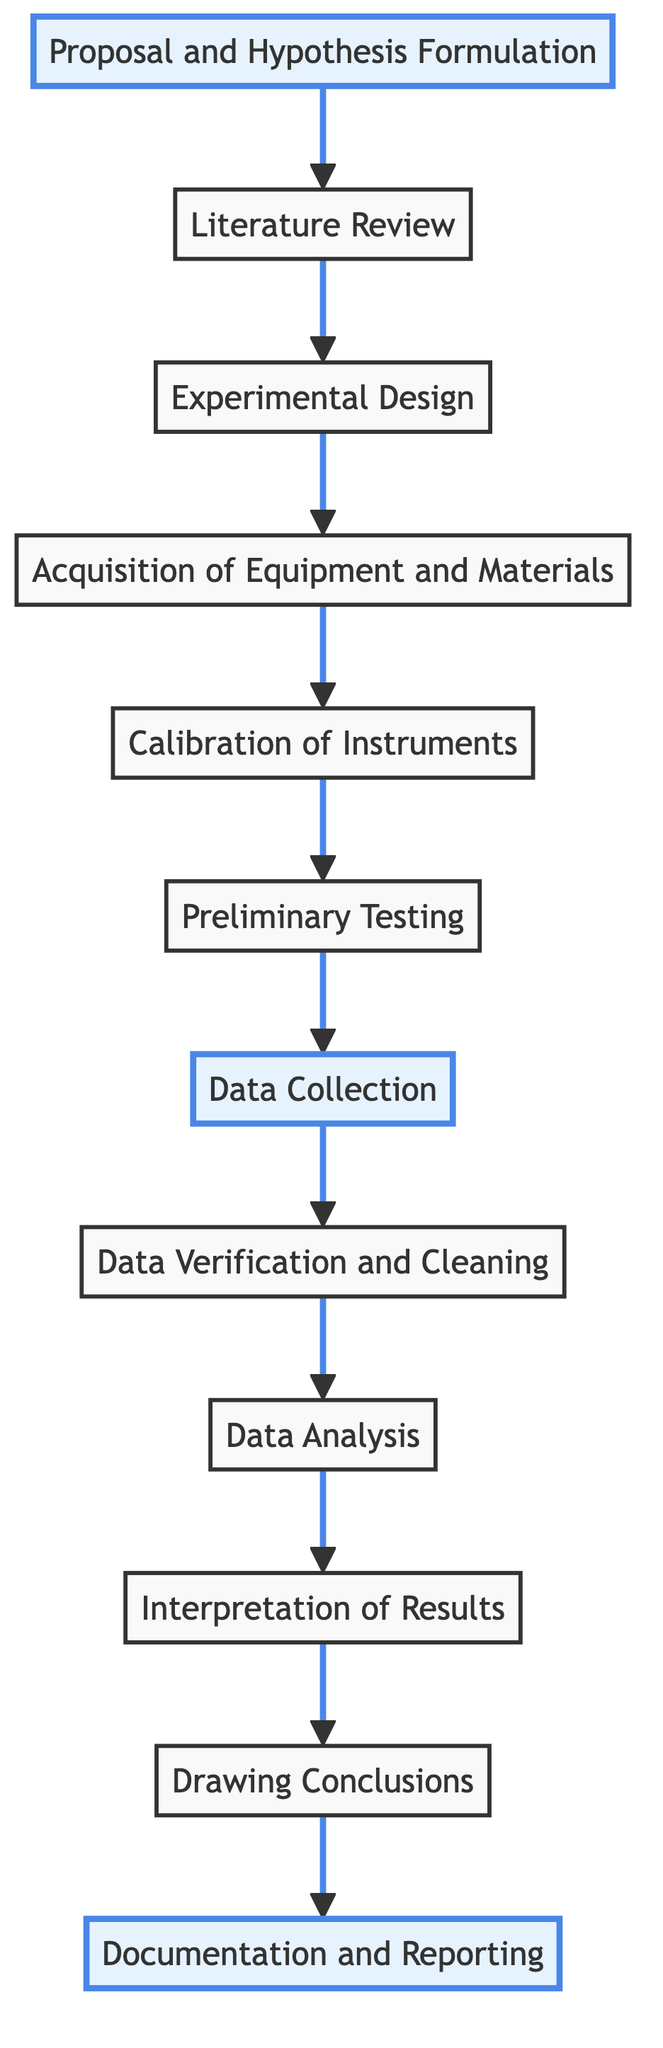What is the first step in the experimental timeline? The first step in the timeline is indicated by the bottommost node, "Proposal and Hypothesis Formulation."
Answer: Proposal and Hypothesis Formulation How many total steps are present in the diagram? Counting all the nodes in the flow chart from the bottom to the top results in a total of twelve distinct steps.
Answer: 12 Which step comes immediately after "Data Collection"? By following the arrow from the "Data Collection" node, the next step is "Data Verification and Cleaning."
Answer: Data Verification and Cleaning What is the last step listed in the process? The last step at the topmost position in the flow chart is "Documentation and Reporting."
Answer: Documentation and Reporting Identify the steps that involve direct interaction with instruments. The relevant steps involving direct interaction with instruments are "Calibration of Instruments," "Preliminary Testing," and "Data Collection," each of which requires meticulous handling of instruments.
Answer: Calibration of Instruments; Preliminary Testing; Data Collection Which steps are indicated with bold font? The nodes marked with bold font in the diagram are "Proposal and Hypothesis Formulation," "Data Collection," and "Documentation and Reporting," highlighting their significance in the process.
Answer: Proposal and Hypothesis Formulation; Data Collection; Documentation and Reporting Is "Literature Review" before or after "Experimental Design"? Since the arrow flows from "Literature Review" to "Experimental Design," it indicates that "Literature Review" occurs before "Experimental Design."
Answer: Before What is the relationship between "Data Analysis" and "Drawing Conclusions"? The diagram shows a direct arrow from "Data Analysis" to "Drawing Conclusions," establishing that "Data Analysis" is a prerequisite for arriving at "Drawing Conclusions."
Answer: Direct relationship; Data Analysis precedes Drawing Conclusions Which step is most likely to require the use of statistical tools? The step titled "Data Analysis" is specifically intended to employ statistical analysis and computational tools.
Answer: Data Analysis 